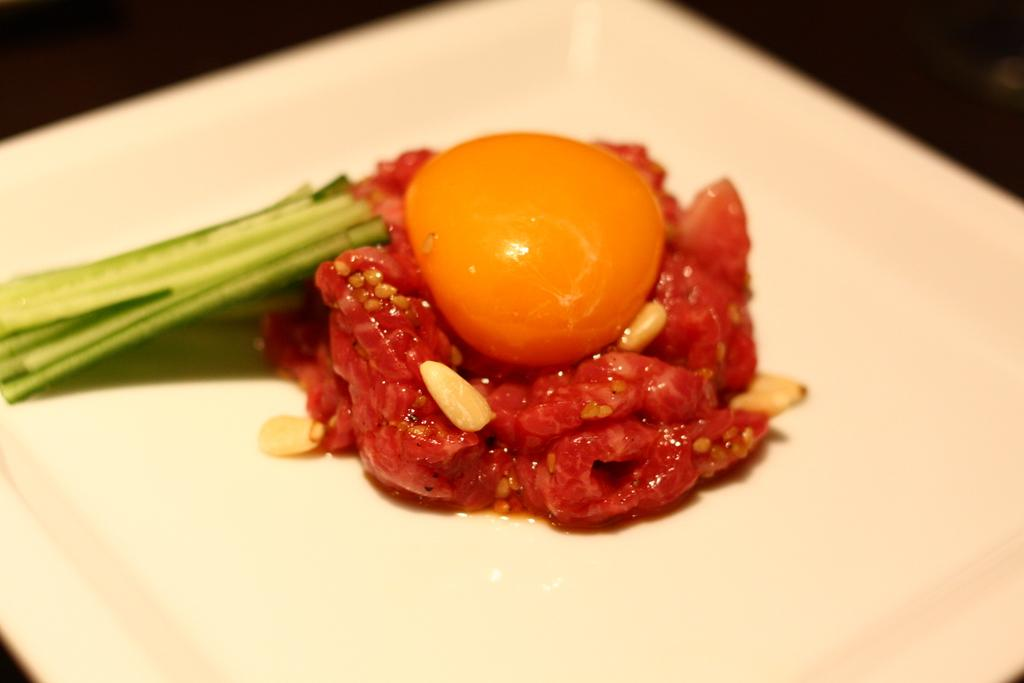What is the main subject of the image? The main subject of the image is a food item served in a plate. Can you describe the food item in the plate? Unfortunately, the specific food item cannot be determined from the given facts. What is the purpose of the plate in the image? The plate is used to serve the food item in the image. What role does the father play in the image? There is no mention of a father or any person in the image, so it is not possible to determine their role. What event is taking place in the image? The given facts do not mention any event or specific context, so it is not possible to determine what event, if any, is taking place in the image. 